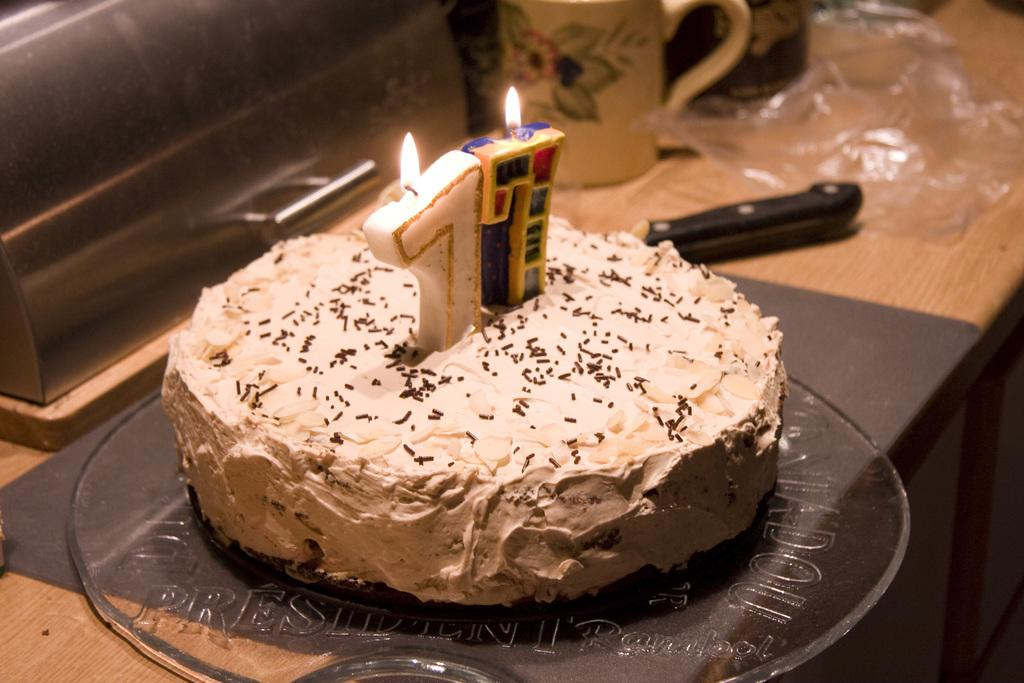What is the main object on the table in the image? There is a cake on the table in the image. What is placed on top of the cake? There are two candles on the cake. What utensil is present on the table? There is a knife on the table. What type of container is on the table? There is a cup on the table. What is covering the cake? There is a cover on the table. Can you describe the object on the table? There is an object on the table, but its specific details are not clear from the image. What type of bone is visible in the image? There is no bone present in the image; it features a cake with candles, a knife, a cup, a cover, and an unspecified object on the table. 